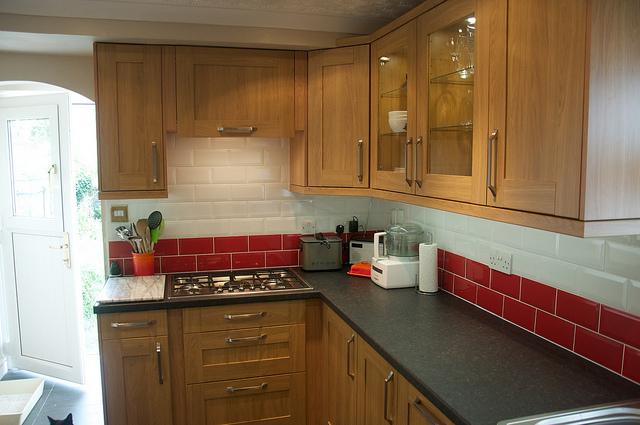How many glass cabinets are there?
Keep it brief. 2. How many rows of brick are red?
Keep it brief. 2. What is the countertop made of?
Short answer required. Granite. Are the countertops made of granite?
Short answer required. No. Do you see any animals in this photo?
Give a very brief answer. No. 